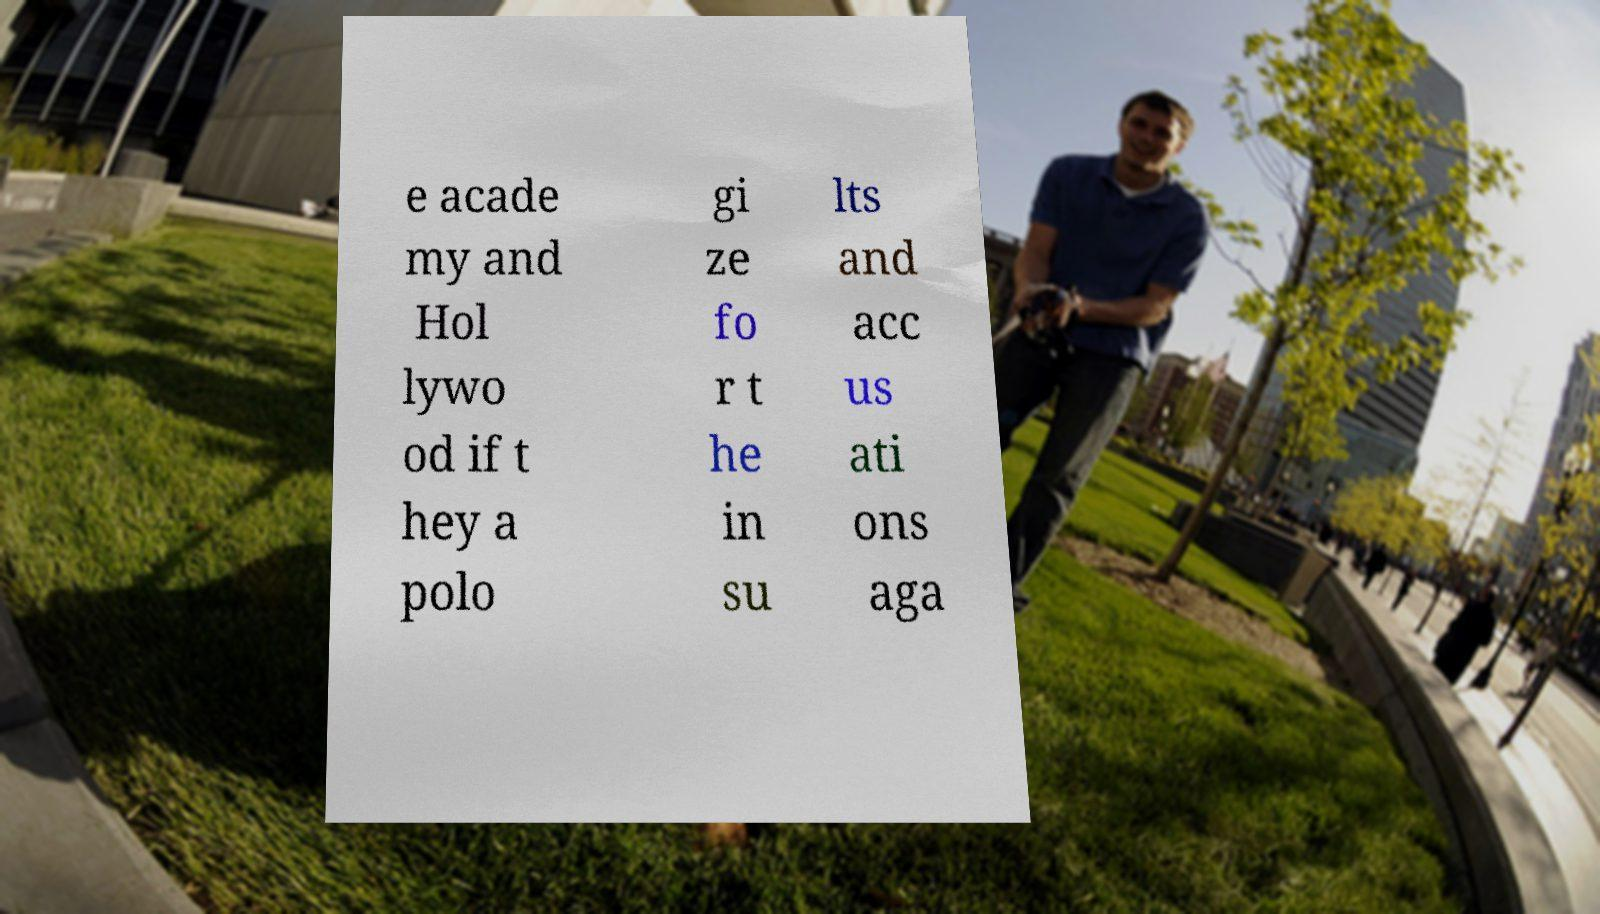What messages or text are displayed in this image? I need them in a readable, typed format. e acade my and Hol lywo od if t hey a polo gi ze fo r t he in su lts and acc us ati ons aga 